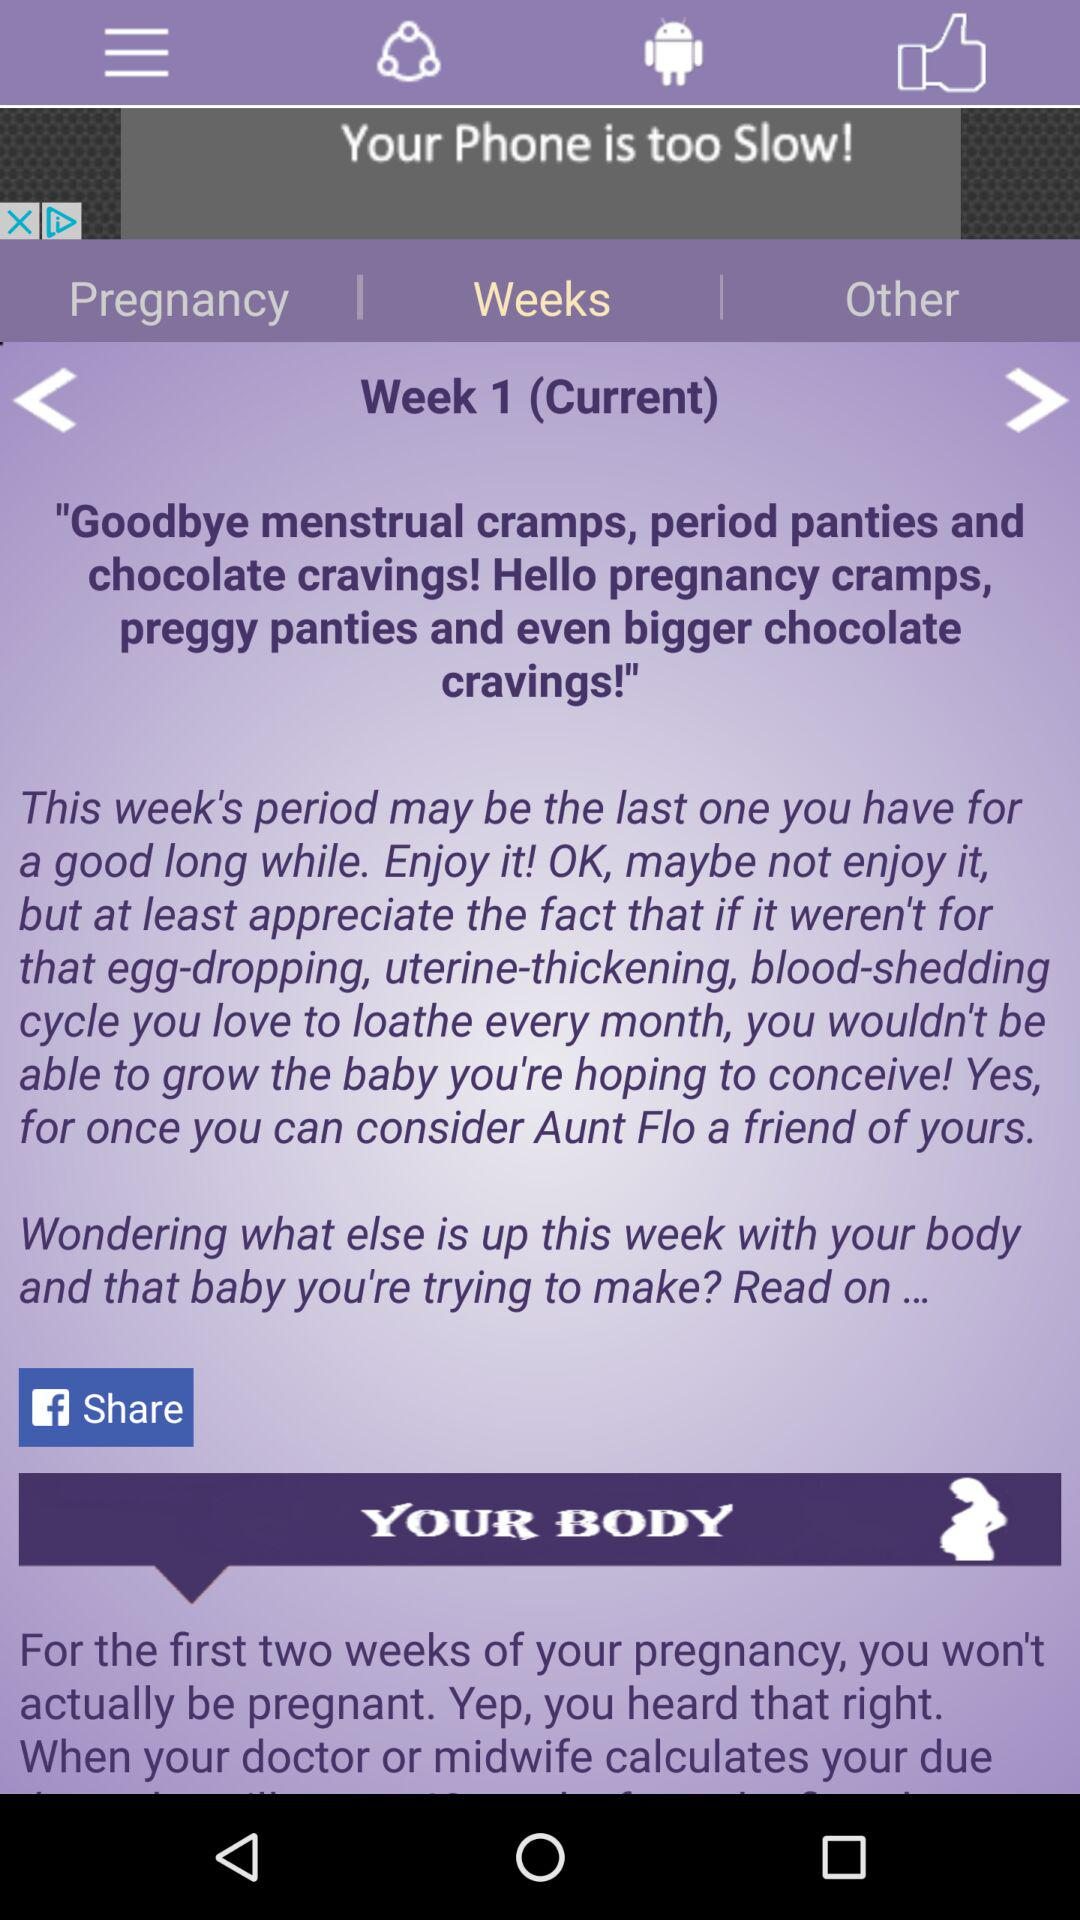How many weeks into pregnancy is the user?
Answer the question using a single word or phrase. 1 